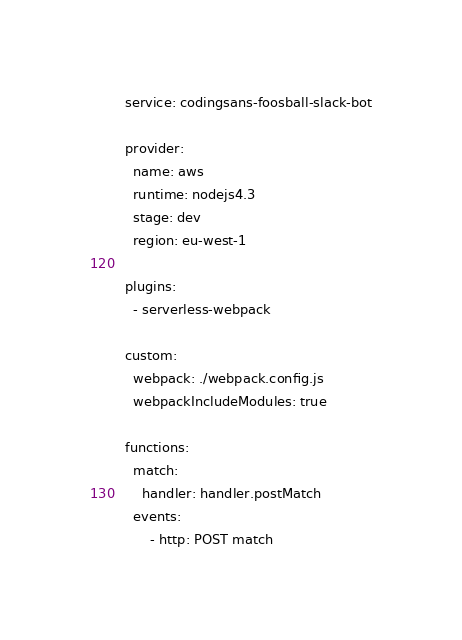<code> <loc_0><loc_0><loc_500><loc_500><_YAML_>service: codingsans-foosball-slack-bot

provider:
  name: aws
  runtime: nodejs4.3
  stage: dev
  region: eu-west-1

plugins:
  - serverless-webpack

custom:
  webpack: ./webpack.config.js
  webpackIncludeModules: true

functions:
  match:
    handler: handler.postMatch
  events:
      - http: POST match
</code> 